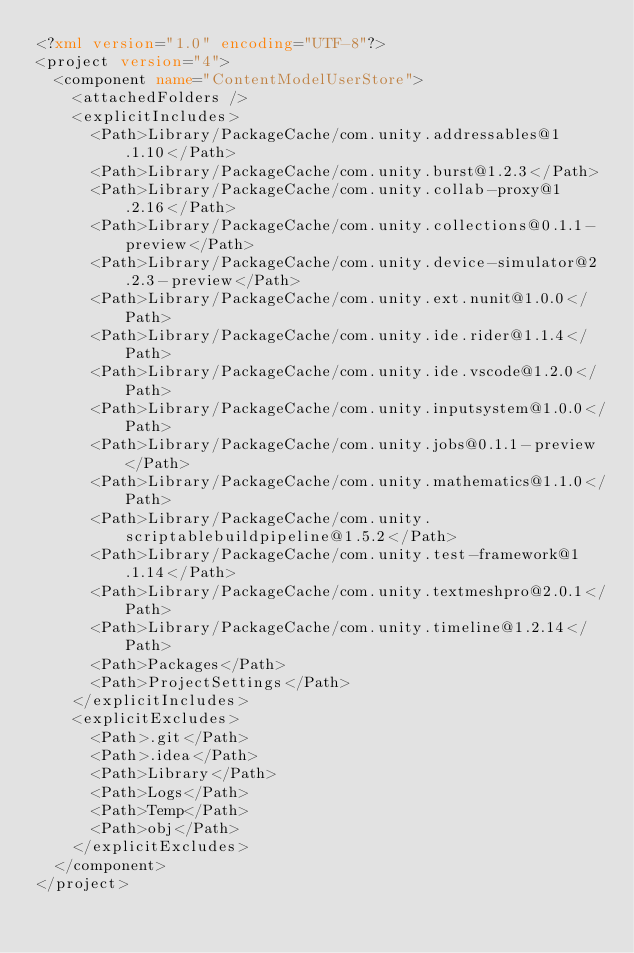Convert code to text. <code><loc_0><loc_0><loc_500><loc_500><_XML_><?xml version="1.0" encoding="UTF-8"?>
<project version="4">
  <component name="ContentModelUserStore">
    <attachedFolders />
    <explicitIncludes>
      <Path>Library/PackageCache/com.unity.addressables@1.1.10</Path>
      <Path>Library/PackageCache/com.unity.burst@1.2.3</Path>
      <Path>Library/PackageCache/com.unity.collab-proxy@1.2.16</Path>
      <Path>Library/PackageCache/com.unity.collections@0.1.1-preview</Path>
      <Path>Library/PackageCache/com.unity.device-simulator@2.2.3-preview</Path>
      <Path>Library/PackageCache/com.unity.ext.nunit@1.0.0</Path>
      <Path>Library/PackageCache/com.unity.ide.rider@1.1.4</Path>
      <Path>Library/PackageCache/com.unity.ide.vscode@1.2.0</Path>
      <Path>Library/PackageCache/com.unity.inputsystem@1.0.0</Path>
      <Path>Library/PackageCache/com.unity.jobs@0.1.1-preview</Path>
      <Path>Library/PackageCache/com.unity.mathematics@1.1.0</Path>
      <Path>Library/PackageCache/com.unity.scriptablebuildpipeline@1.5.2</Path>
      <Path>Library/PackageCache/com.unity.test-framework@1.1.14</Path>
      <Path>Library/PackageCache/com.unity.textmeshpro@2.0.1</Path>
      <Path>Library/PackageCache/com.unity.timeline@1.2.14</Path>
      <Path>Packages</Path>
      <Path>ProjectSettings</Path>
    </explicitIncludes>
    <explicitExcludes>
      <Path>.git</Path>
      <Path>.idea</Path>
      <Path>Library</Path>
      <Path>Logs</Path>
      <Path>Temp</Path>
      <Path>obj</Path>
    </explicitExcludes>
  </component>
</project></code> 